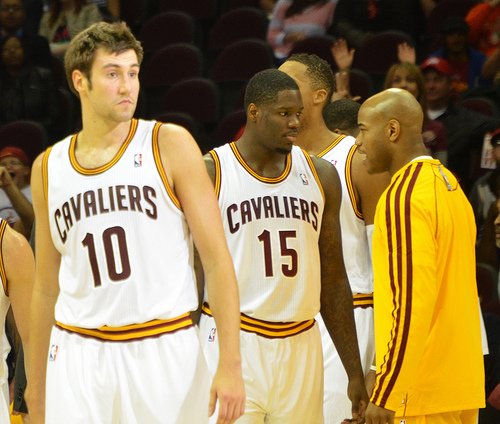<image>
Is the man next to the man? Yes. The man is positioned adjacent to the man, located nearby in the same general area. 